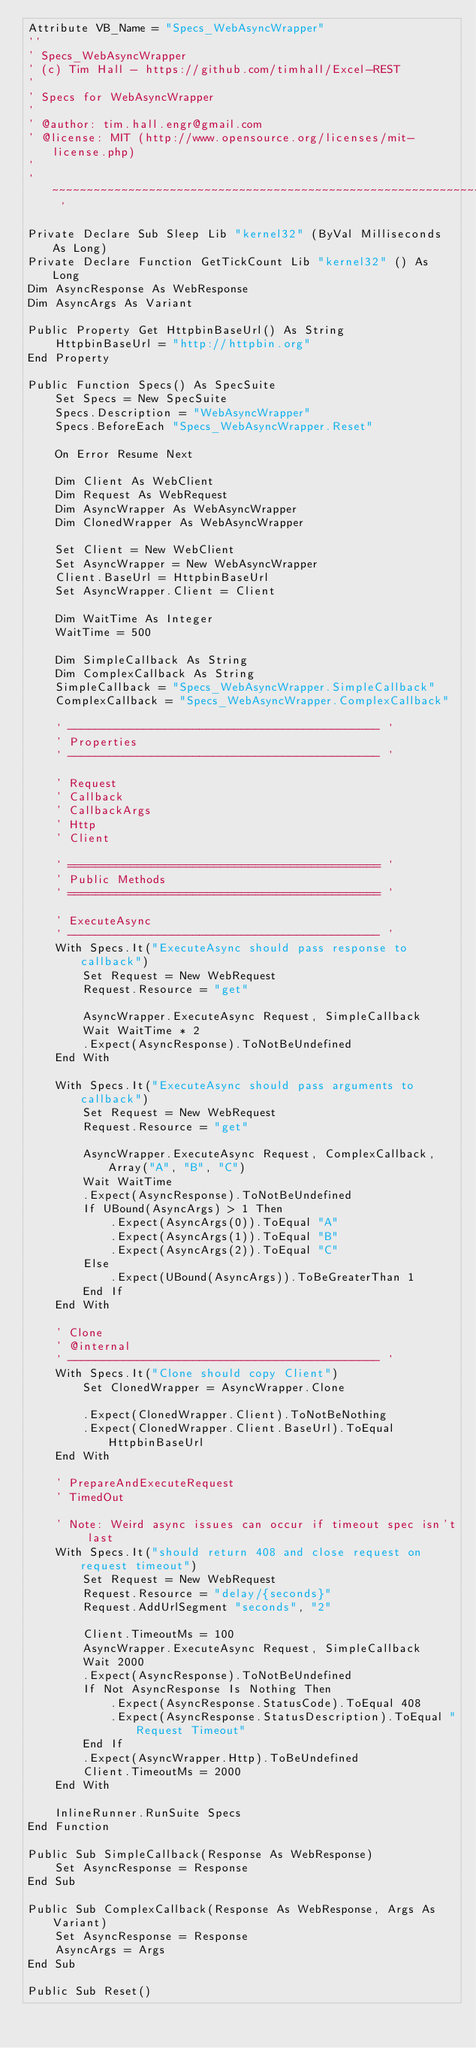<code> <loc_0><loc_0><loc_500><loc_500><_VisualBasic_>Attribute VB_Name = "Specs_WebAsyncWrapper"
''
' Specs_WebAsyncWrapper
' (c) Tim Hall - https://github.com/timhall/Excel-REST
'
' Specs for WebAsyncWrapper
'
' @author: tim.hall.engr@gmail.com
' @license: MIT (http://www.opensource.org/licenses/mit-license.php)
'
' ~~~~~~~~~~~~~~~~~~~~~~~~~~~~~~~~~~~~~~~~~~~~~~~~~~~~~~~~~~~~~~~~~~~~~~ '

Private Declare Sub Sleep Lib "kernel32" (ByVal Milliseconds As Long)
Private Declare Function GetTickCount Lib "kernel32" () As Long
Dim AsyncResponse As WebResponse
Dim AsyncArgs As Variant

Public Property Get HttpbinBaseUrl() As String
    HttpbinBaseUrl = "http://httpbin.org"
End Property

Public Function Specs() As SpecSuite
    Set Specs = New SpecSuite
    Specs.Description = "WebAsyncWrapper"
    Specs.BeforeEach "Specs_WebAsyncWrapper.Reset"
    
    On Error Resume Next
    
    Dim Client As WebClient
    Dim Request As WebRequest
    Dim AsyncWrapper As WebAsyncWrapper
    Dim ClonedWrapper As WebAsyncWrapper
    
    Set Client = New WebClient
    Set AsyncWrapper = New WebAsyncWrapper
    Client.BaseUrl = HttpbinBaseUrl
    Set AsyncWrapper.Client = Client
    
    Dim WaitTime As Integer
    WaitTime = 500
    
    Dim SimpleCallback As String
    Dim ComplexCallback As String
    SimpleCallback = "Specs_WebAsyncWrapper.SimpleCallback"
    ComplexCallback = "Specs_WebAsyncWrapper.ComplexCallback"
    
    ' --------------------------------------------- '
    ' Properties
    ' --------------------------------------------- '
    
    ' Request
    ' Callback
    ' CallbackArgs
    ' Http
    ' Client
    
    ' ============================================= '
    ' Public Methods
    ' ============================================= '
    
    ' ExecuteAsync
    ' --------------------------------------------- '
    With Specs.It("ExecuteAsync should pass response to callback")
        Set Request = New WebRequest
        Request.Resource = "get"
        
        AsyncWrapper.ExecuteAsync Request, SimpleCallback
        Wait WaitTime * 2
        .Expect(AsyncResponse).ToNotBeUndefined
    End With
    
    With Specs.It("ExecuteAsync should pass arguments to callback")
        Set Request = New WebRequest
        Request.Resource = "get"
        
        AsyncWrapper.ExecuteAsync Request, ComplexCallback, Array("A", "B", "C")
        Wait WaitTime
        .Expect(AsyncResponse).ToNotBeUndefined
        If UBound(AsyncArgs) > 1 Then
            .Expect(AsyncArgs(0)).ToEqual "A"
            .Expect(AsyncArgs(1)).ToEqual "B"
            .Expect(AsyncArgs(2)).ToEqual "C"
        Else
            .Expect(UBound(AsyncArgs)).ToBeGreaterThan 1
        End If
    End With
    
    ' Clone
    ' @internal
    ' --------------------------------------------- '
    With Specs.It("Clone should copy Client")
        Set ClonedWrapper = AsyncWrapper.Clone
        
        .Expect(ClonedWrapper.Client).ToNotBeNothing
        .Expect(ClonedWrapper.Client.BaseUrl).ToEqual HttpbinBaseUrl
    End With
    
    ' PrepareAndExecuteRequest
    ' TimedOut
    
    ' Note: Weird async issues can occur if timeout spec isn't last
    With Specs.It("should return 408 and close request on request timeout")
        Set Request = New WebRequest
        Request.Resource = "delay/{seconds}"
        Request.AddUrlSegment "seconds", "2"

        Client.TimeoutMs = 100
        AsyncWrapper.ExecuteAsync Request, SimpleCallback
        Wait 2000
        .Expect(AsyncResponse).ToNotBeUndefined
        If Not AsyncResponse Is Nothing Then
            .Expect(AsyncResponse.StatusCode).ToEqual 408
            .Expect(AsyncResponse.StatusDescription).ToEqual "Request Timeout"
        End If
        .Expect(AsyncWrapper.Http).ToBeUndefined
        Client.TimeoutMs = 2000
    End With
    
    InlineRunner.RunSuite Specs
End Function

Public Sub SimpleCallback(Response As WebResponse)
    Set AsyncResponse = Response
End Sub

Public Sub ComplexCallback(Response As WebResponse, Args As Variant)
    Set AsyncResponse = Response
    AsyncArgs = Args
End Sub

Public Sub Reset()</code> 